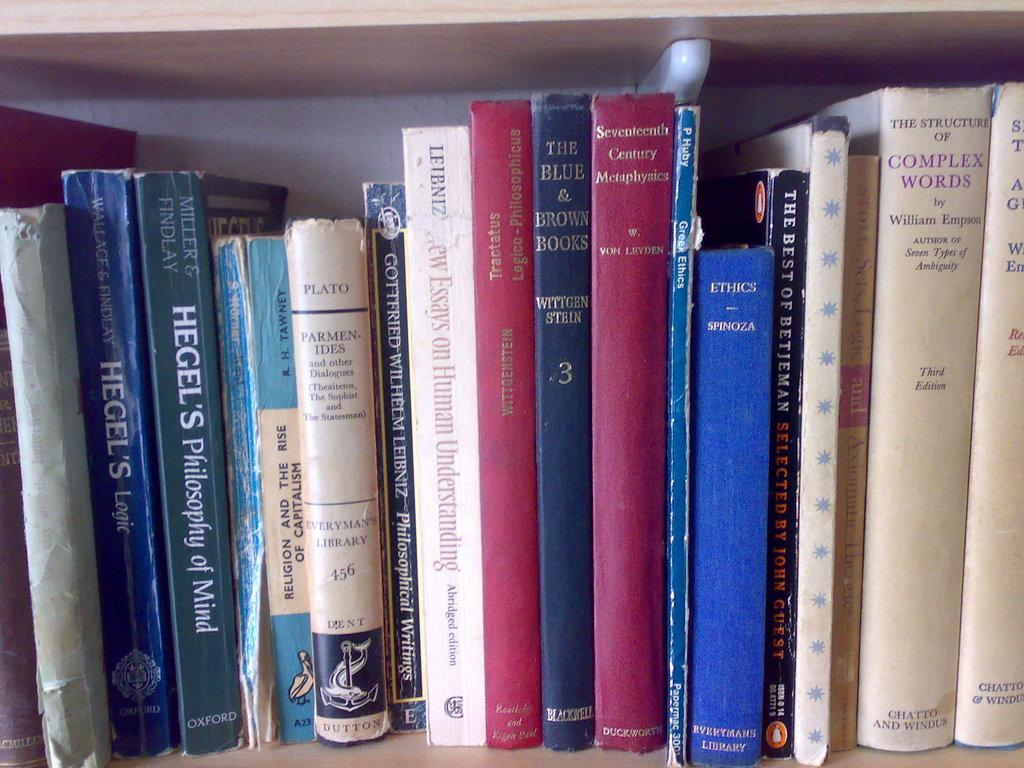<image>
Create a compact narrative representing the image presented. Philosophy books on a shelf, covering Hegel, Plato, and ethics. 